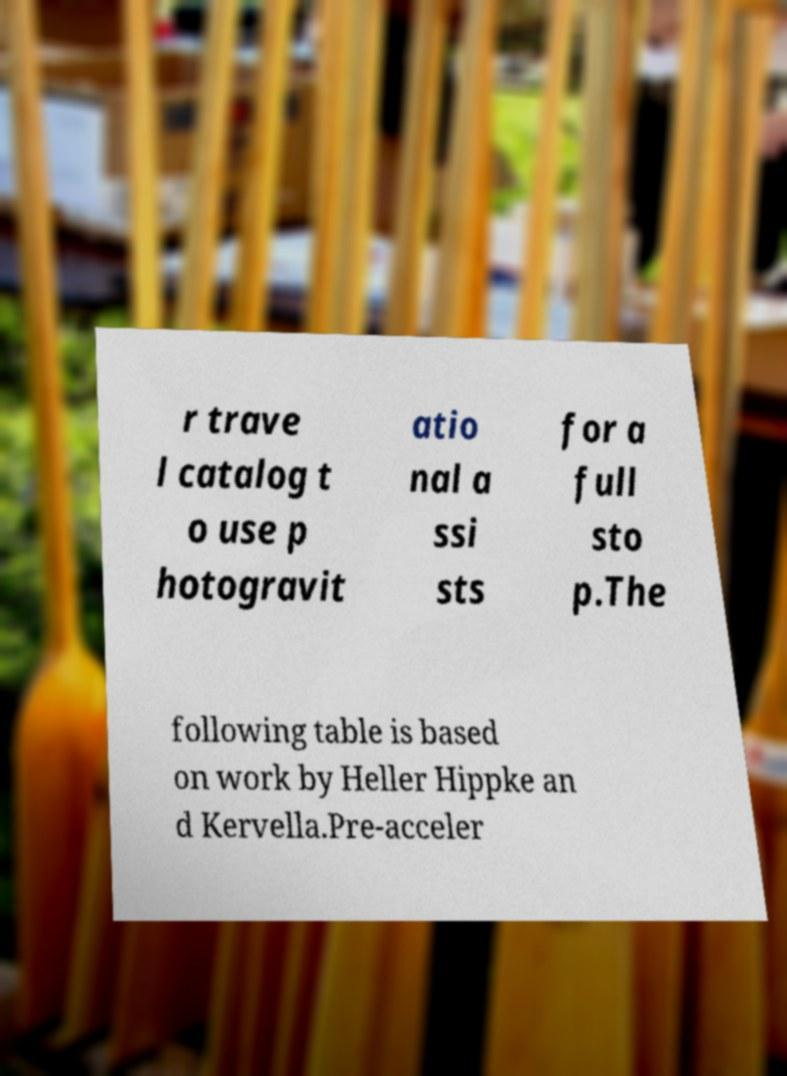Can you accurately transcribe the text from the provided image for me? r trave l catalog t o use p hotogravit atio nal a ssi sts for a full sto p.The following table is based on work by Heller Hippke an d Kervella.Pre-acceler 